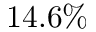Convert formula to latex. <formula><loc_0><loc_0><loc_500><loc_500>1 4 . 6 \%</formula> 